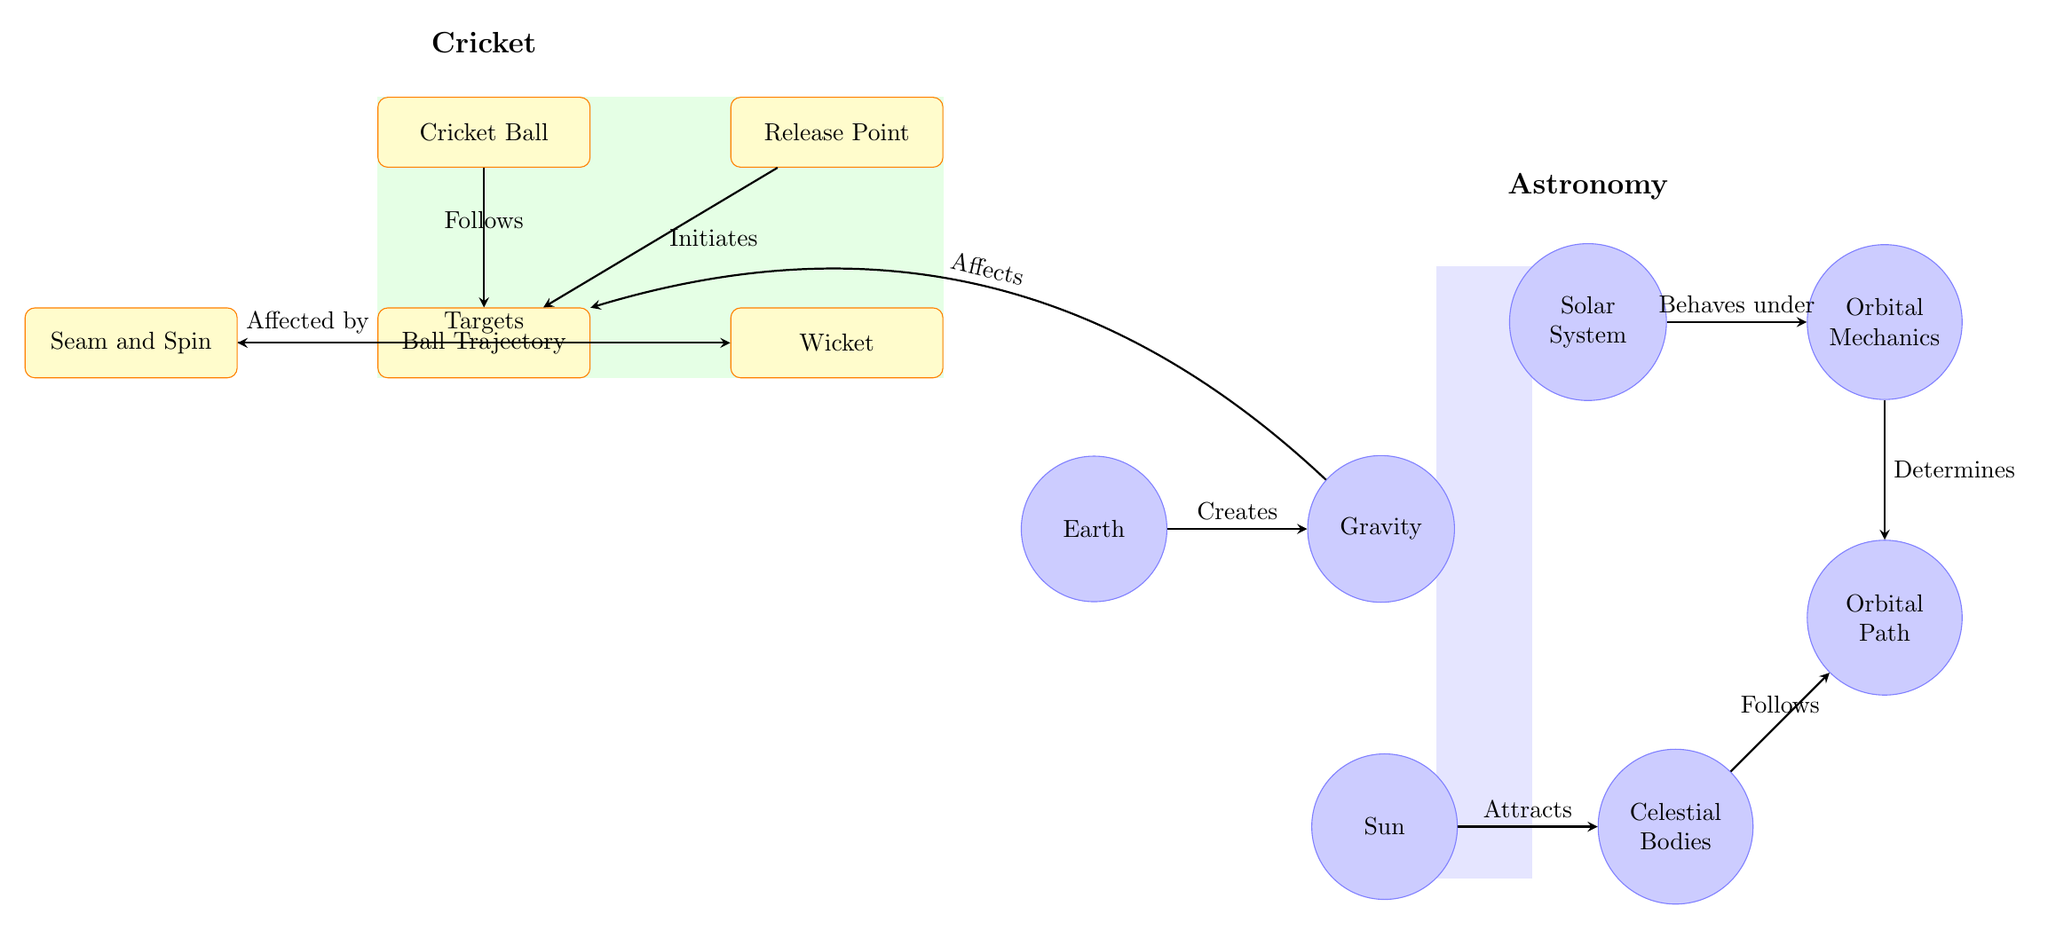What is the starting point of the ball's trajectory? The diagram shows the "Release Point" as the location from which the ball's trajectory initiates. This is indicated by the arrow connecting the release point to the trajectory.
Answer: Release Point How many nodes represent celestial bodies? By examining the diagram, we can see there are four nodes labeled as celestial bodies: Earth, Solar System, Celestial Bodies, and Sun. Therefore, the count of these nodes gives us the answer.
Answer: 4 What effect does gravity have on the ball's trajectory? The diagram illustrates that gravity, created by Earth, "Affects" the ball's trajectory. This is shown by the directional arrow between the gravity and trajectory entities.
Answer: Affects Which entity targets the wicket? In the visual, the "Seam and Spin" node is shown to "Targets" the "Wicket," as indicated by the directed arrow leading from the spin node to the wicket node.
Answer: Seam and Spin What is the relationship between the solar system and orbital mechanics? The diagram states that the solar system "Behaves under" the rules of "Orbital Mechanics," indicated by the arrow connecting these two nodes. This means that the behavior of celestial objects in the solar system is governed by orbital mechanics.
Answer: Behaves under How does the Sun influence celestial bodies? The arrow in the diagram indicates that the "Sun" "Attracts" the node labeled "Celestial Bodies," showing the gravitational influence the Sun has on these bodies.
Answer: Attracts What two factors affect the ball's trajectory directly? From the visual information, the ball's trajectory is affected by both "Spin" and "Gravity," as shown by the arrows linking these nodes to the trajectory node.
Answer: Spin and Gravity What is the ultimate outcome of the orbital mechanics according to the diagram? The diagram conveys that "Orbital Mechanics" "Determines" the "Orbital Path," meaning that the mechanics of orbits are responsible for defining the paths that celestial bodies follow through space.
Answer: Determines What is the primary action at the release point? The diagram shows that the "Release Point" "Initiates" the ball's trajectory, indicating that this is where the action begins as the ball is thrown.
Answer: Initiates 